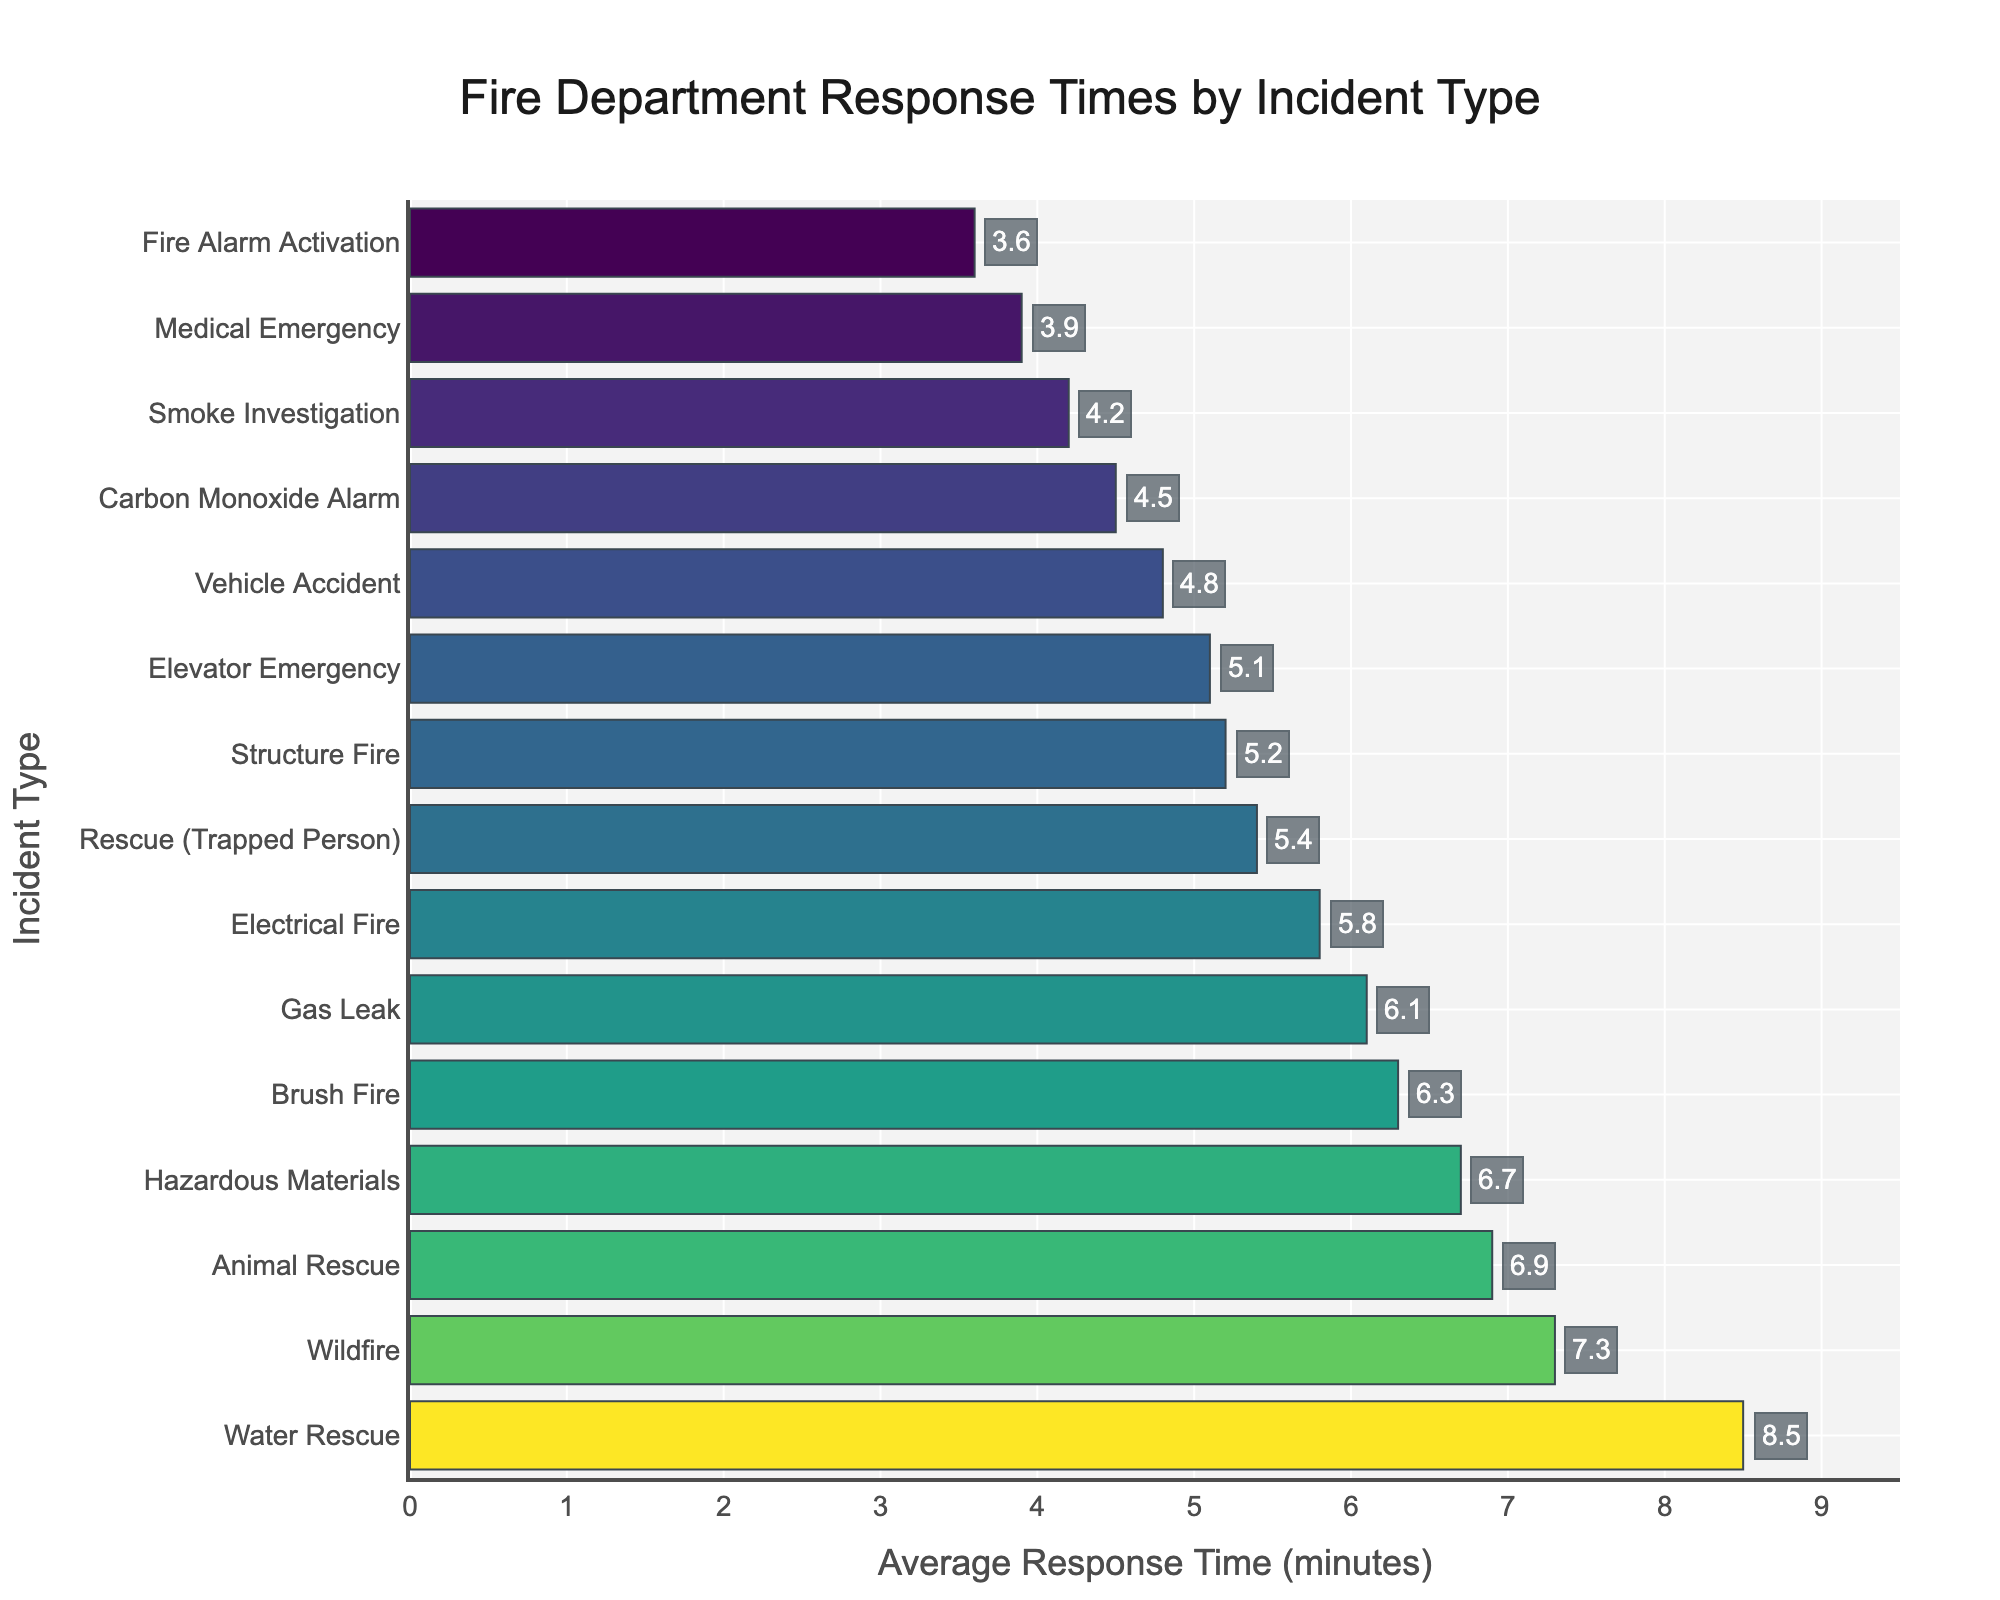What is the average response time for the three quickest incident types? We need to find the response times for the three quickest incidents and then calculate the average. The three quickest incidents are "Fire Alarm Activation" (3.6 minutes), "Medical Emergency" (3.9 minutes), and "Smoke Investigation" (4.2 minutes). The average is calculated as (3.6 + 3.9 + 4.2) / 3.
Answer: 3.9 minutes Which incident type has the longest average response time? By observing the lengths of the bars, the longest bar corresponds to the "Water Rescue" incident type, which has an average response time of 8.5 minutes.
Answer: Water Rescue How much longer is the response time for an "Animal Rescue" compared to an "Electrical Fire"? The average response time for an "Animal Rescue" is 6.9 minutes and for an "Electrical Fire" is 5.8 minutes. The difference is 6.9 - 5.8.
Answer: 1.1 minutes Compare the response times: Is the "Gas Leak" response time longer or shorter than the "Brush Fire" response time? The average response time for "Gas Leak" is 6.1 minutes, while for "Brush Fire" it is 6.3 minutes. Comparing these values, 6.1 is shorter than 6.3.
Answer: Shorter What is the combined average response time for "Vehicle Accident", "Medical Emergency", and "Carbon Monoxide Alarm"? Adding the average response times together, Vehicle Accident (4.8 minutes), Medical Emergency (3.9 minutes), and Carbon Monoxide Alarm (4.5 minutes), we get 4.8 + 3.9 + 4.5.
Answer: 13.2 minutes How does the color and length of the bar correspond to the average response time for incident types? The bar length represents the average response time in minutes; longer bars represent longer response times. The color shade, which varies in a gradient, also indicates the response time, with lighter colors generally representing higher values.
Answer: Length and color of bars correspond to response time What is the range of response times across all incident types? The shortest response time is for "Fire Alarm Activation" at 3.6 minutes, and the longest is for "Water Rescue" at 8.5 minutes. The range is calculated by subtracting the smallest value from the largest value, 8.5 - 3.6.
Answer: 4.9 minutes Which incidents have an average response time greater than 6 minutes? We need to identify incident types with bars extending beyond the 6-minute mark. These are "Gas Leak" (6.1 minutes), "Wildfire" (7.3 minutes), "Water Rescue" (8.5 minutes), "Hazardous Materials" (6.7 minutes), "Animal Rescue" (6.9 minutes), and "Brush Fire" (6.3 minutes).
Answer: Gas Leak, Wildfire, Water Rescue, Hazardous Materials, Animal Rescue, Brush Fire What is the difference in average response time between the "Structure Fire" and "Rescue (Trapped Person)"? The average response time for "Structure Fire" is 5.2 minutes, and for "Rescue (Trapped Person)" it is 5.4 minutes. The difference is calculated as 5.4 - 5.2.
Answer: 0.2 minutes 